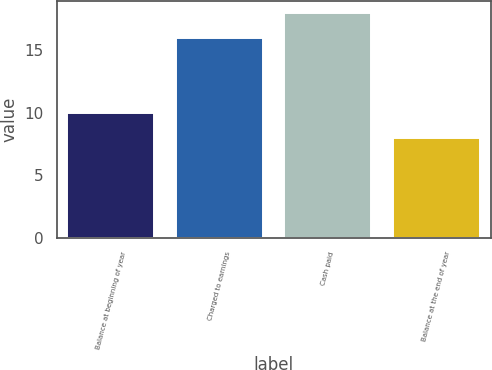Convert chart. <chart><loc_0><loc_0><loc_500><loc_500><bar_chart><fcel>Balance at beginning of year<fcel>Charged to earnings<fcel>Cash paid<fcel>Balance at the end of year<nl><fcel>10<fcel>16<fcel>18<fcel>8<nl></chart> 